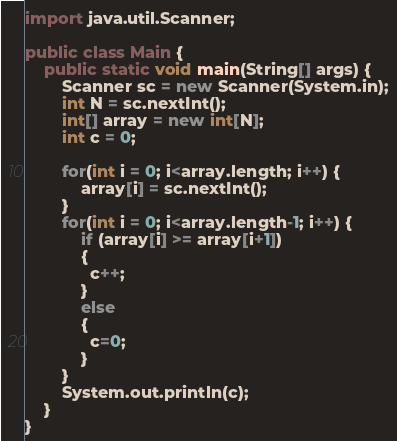Convert code to text. <code><loc_0><loc_0><loc_500><loc_500><_Java_>import java.util.Scanner;
 
public class Main {
	public static void main(String[] args) {
		Scanner sc = new Scanner(System.in);
		int N = sc.nextInt();
		int[] array = new int[N];
		int c = 0;
		
		for(int i = 0; i<array.length; i++) {
			array[i] = sc.nextInt();
		}		
		for(int i = 0; i<array.length-1; i++) {
			if (array[i] >= array[i+1])
            {	
              c++;
            }
          	else
            {
              c=0;
            }
		}
		System.out.println(c);
	}
}</code> 